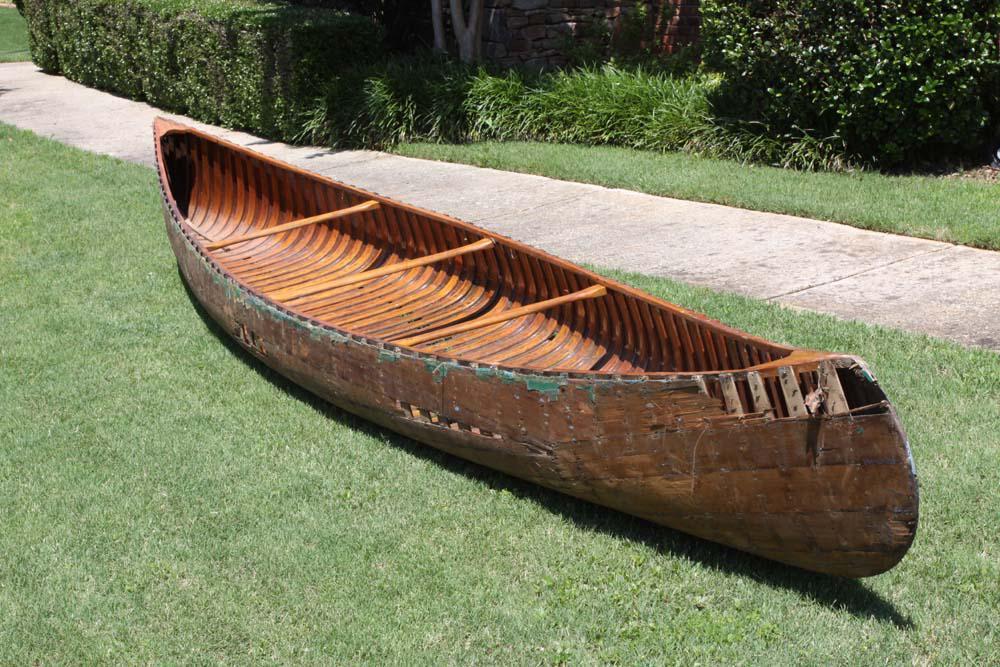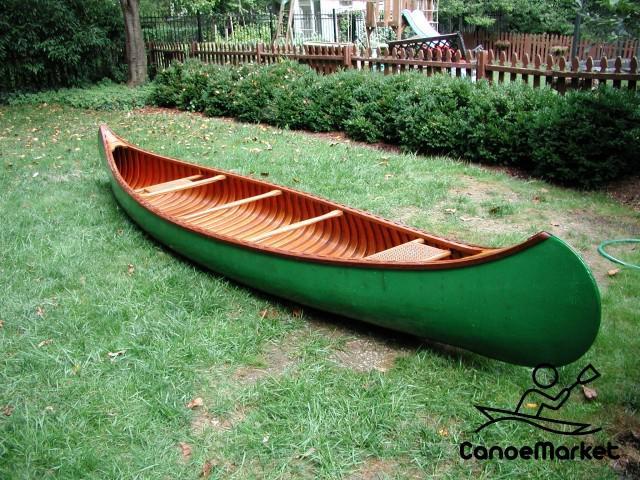The first image is the image on the left, the second image is the image on the right. Given the left and right images, does the statement "The right image shows a green canoe lying on grass." hold true? Answer yes or no. Yes. The first image is the image on the left, the second image is the image on the right. Examine the images to the left and right. Is the description "Both canoes are outside and on dry land." accurate? Answer yes or no. Yes. 